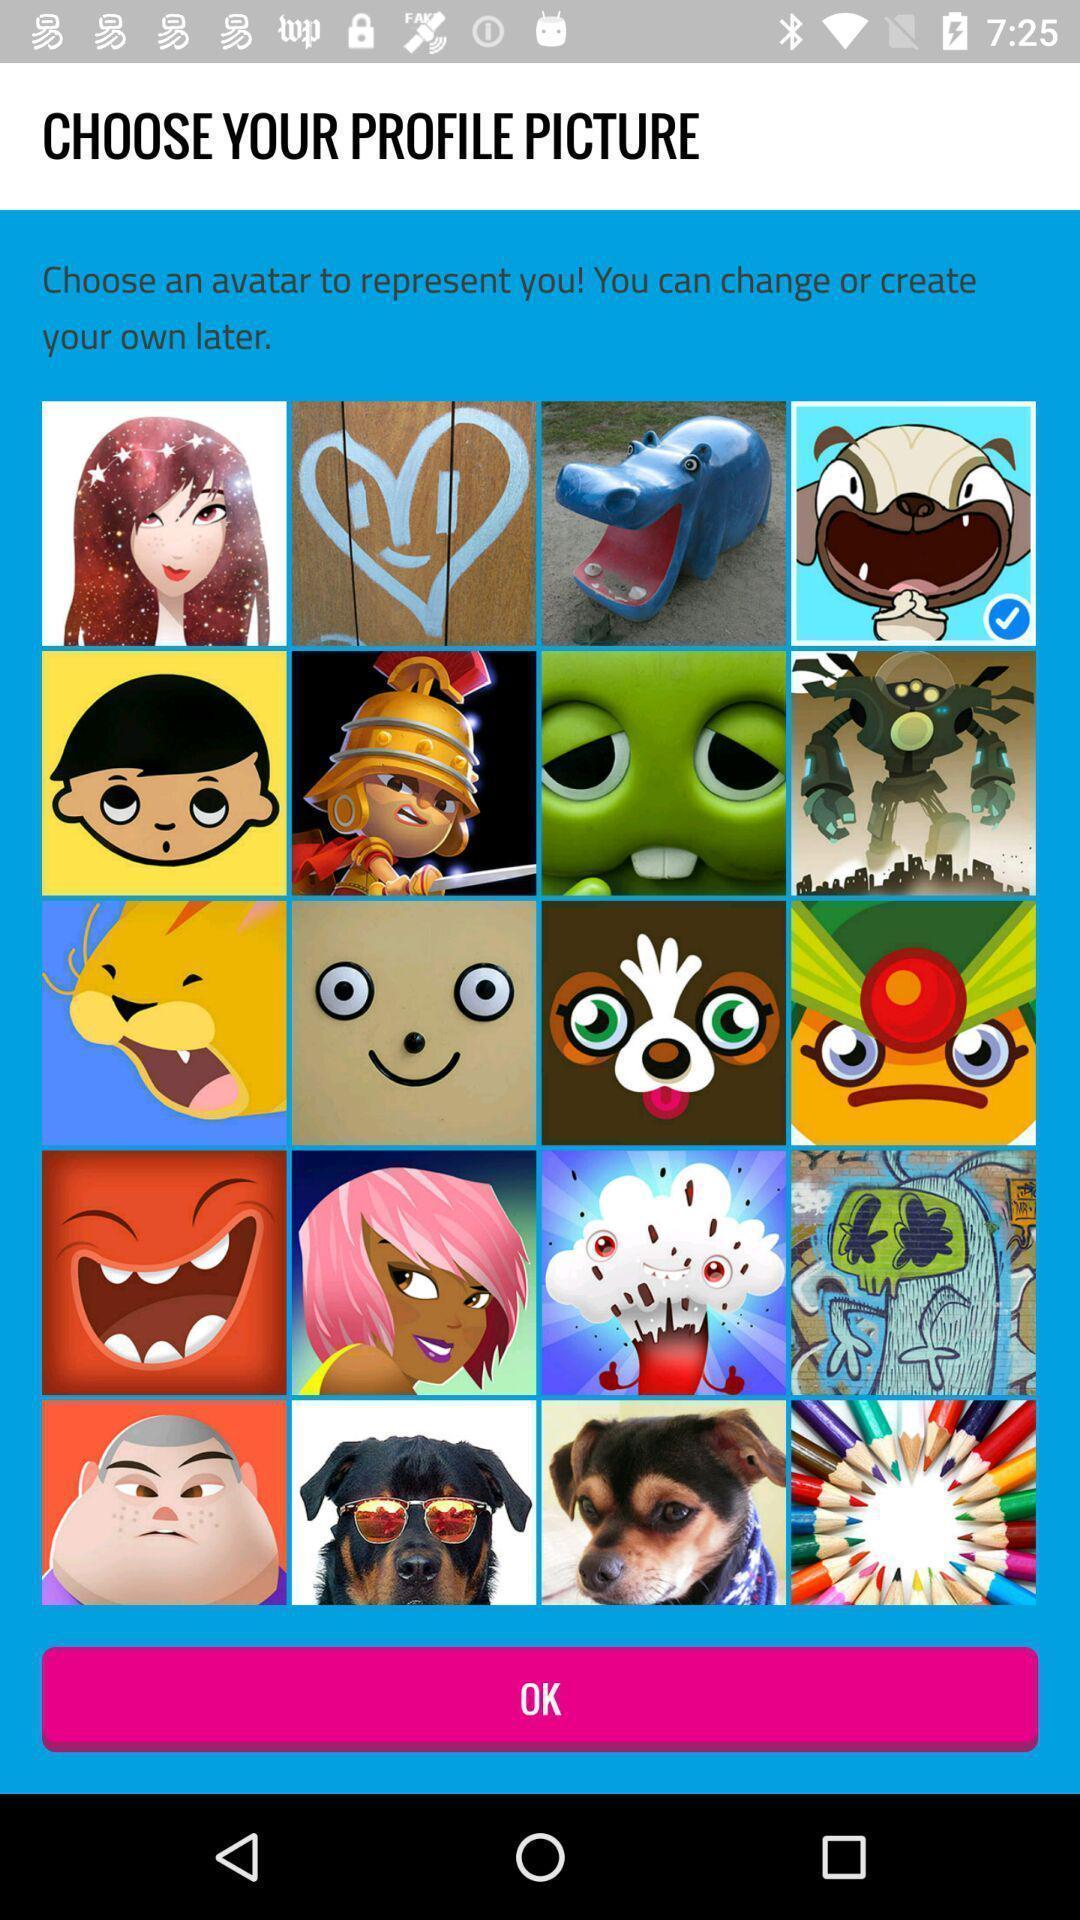Tell me about the visual elements in this screen capture. Page that shows the profile pictures with ok button. 